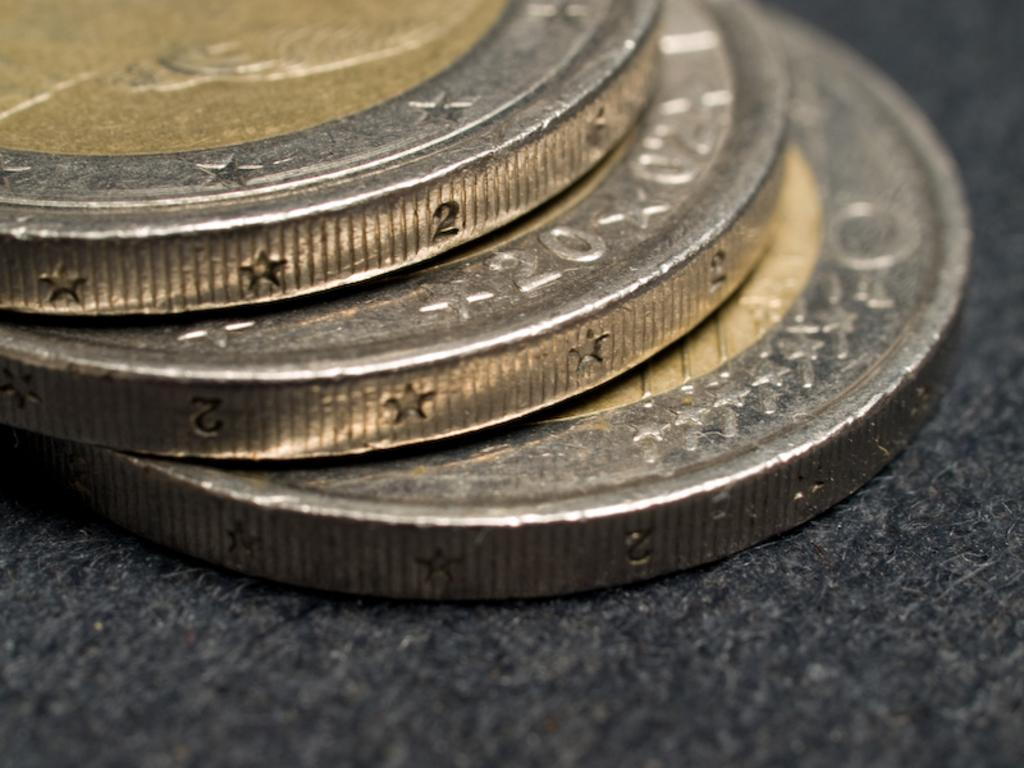What type of objects are present in the image? There are metal coins in the image. Where are the metal coins located? The metal coins are on a surface. What type of bubbles can be seen in the image? There are no bubbles present in the image; it features metal coins on a surface. What type of eggnog is being served in the image? There is no eggnog present in the image; it features metal coins on a surface. 